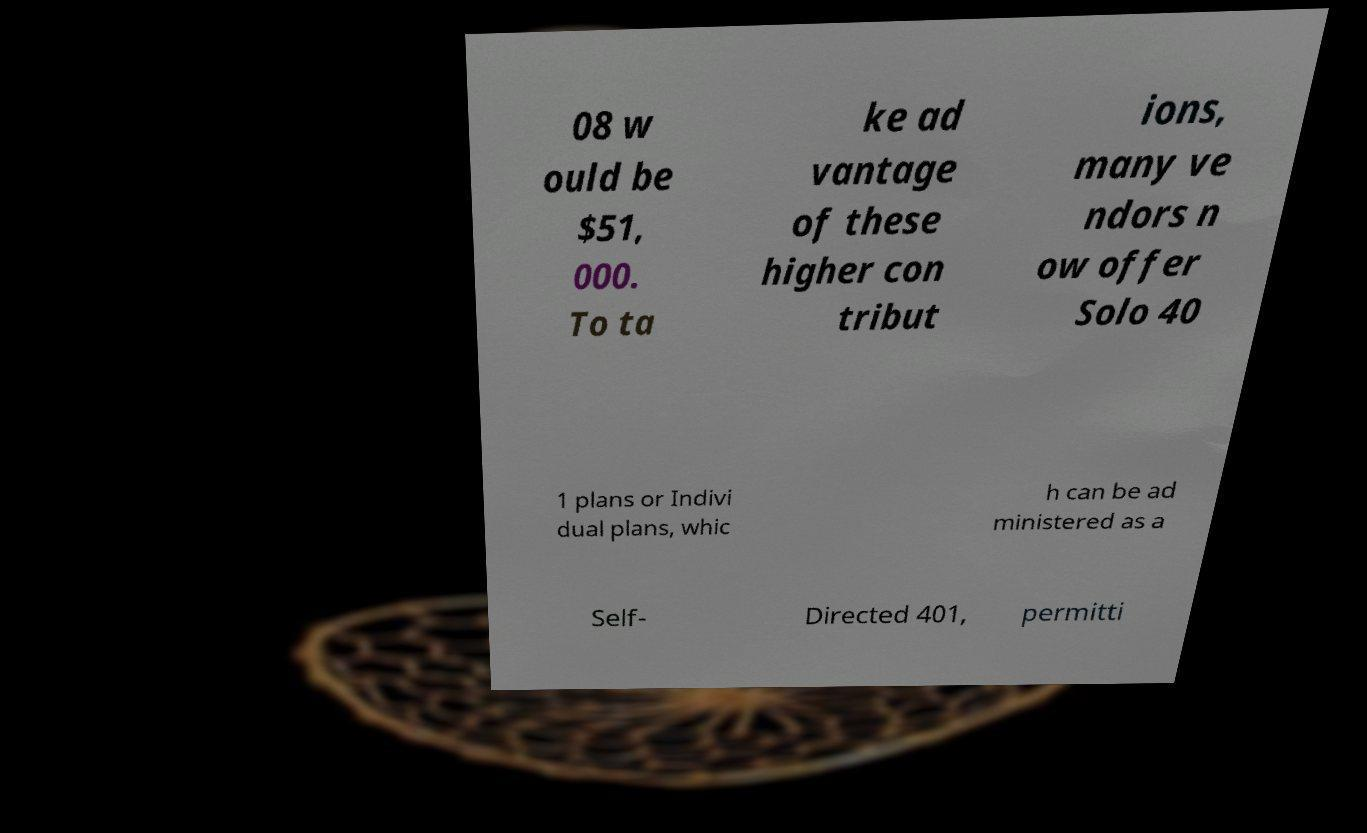Can you accurately transcribe the text from the provided image for me? 08 w ould be $51, 000. To ta ke ad vantage of these higher con tribut ions, many ve ndors n ow offer Solo 40 1 plans or Indivi dual plans, whic h can be ad ministered as a Self- Directed 401, permitti 